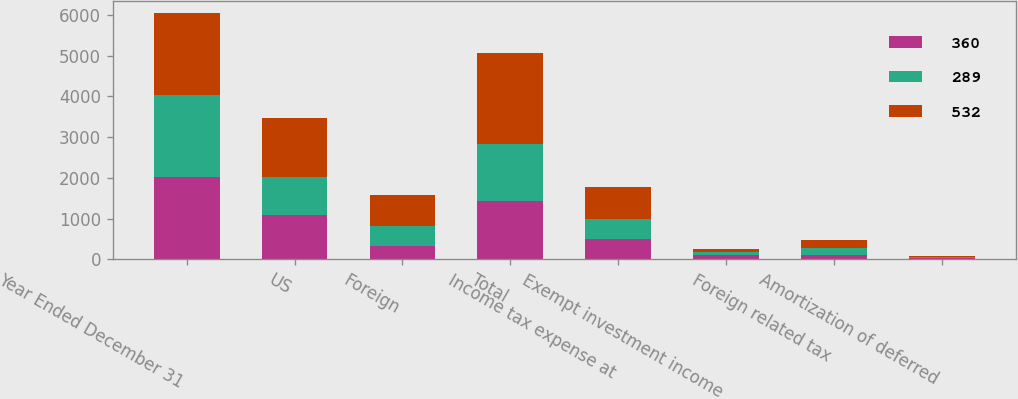<chart> <loc_0><loc_0><loc_500><loc_500><stacked_bar_chart><ecel><fcel>Year Ended December 31<fcel>US<fcel>Foreign<fcel>Total<fcel>Income tax expense at<fcel>Exempt investment income<fcel>Foreign related tax<fcel>Amortization of deferred<nl><fcel>360<fcel>2013<fcel>1097<fcel>332<fcel>1429<fcel>500<fcel>99<fcel>117<fcel>31<nl><fcel>289<fcel>2012<fcel>911<fcel>488<fcel>1399<fcel>490<fcel>86<fcel>152<fcel>31<nl><fcel>532<fcel>2011<fcel>1466<fcel>760<fcel>2226<fcel>779<fcel>76<fcel>203<fcel>30<nl></chart> 